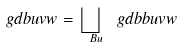<formula> <loc_0><loc_0><loc_500><loc_500>\ g d b u v w = \bigsqcup _ { \ B u } \ g d b b u v w</formula> 